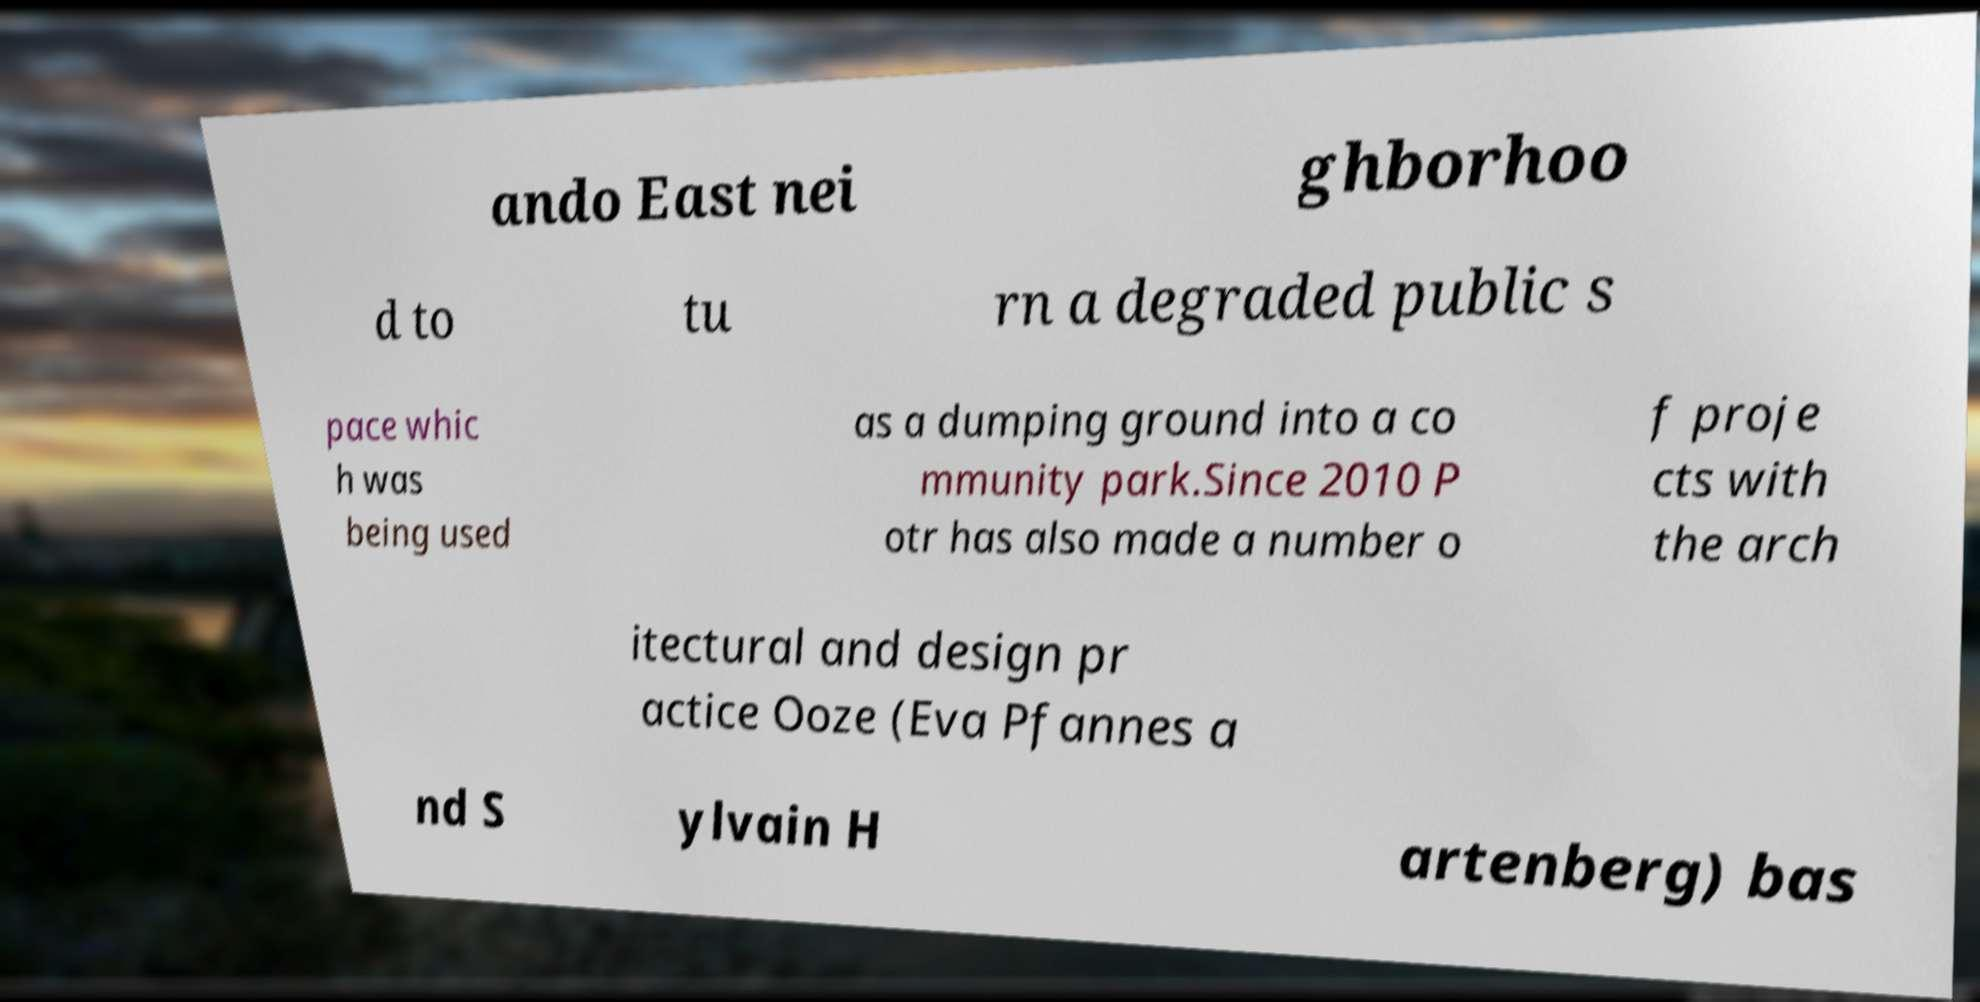Please identify and transcribe the text found in this image. ando East nei ghborhoo d to tu rn a degraded public s pace whic h was being used as a dumping ground into a co mmunity park.Since 2010 P otr has also made a number o f proje cts with the arch itectural and design pr actice Ooze (Eva Pfannes a nd S ylvain H artenberg) bas 